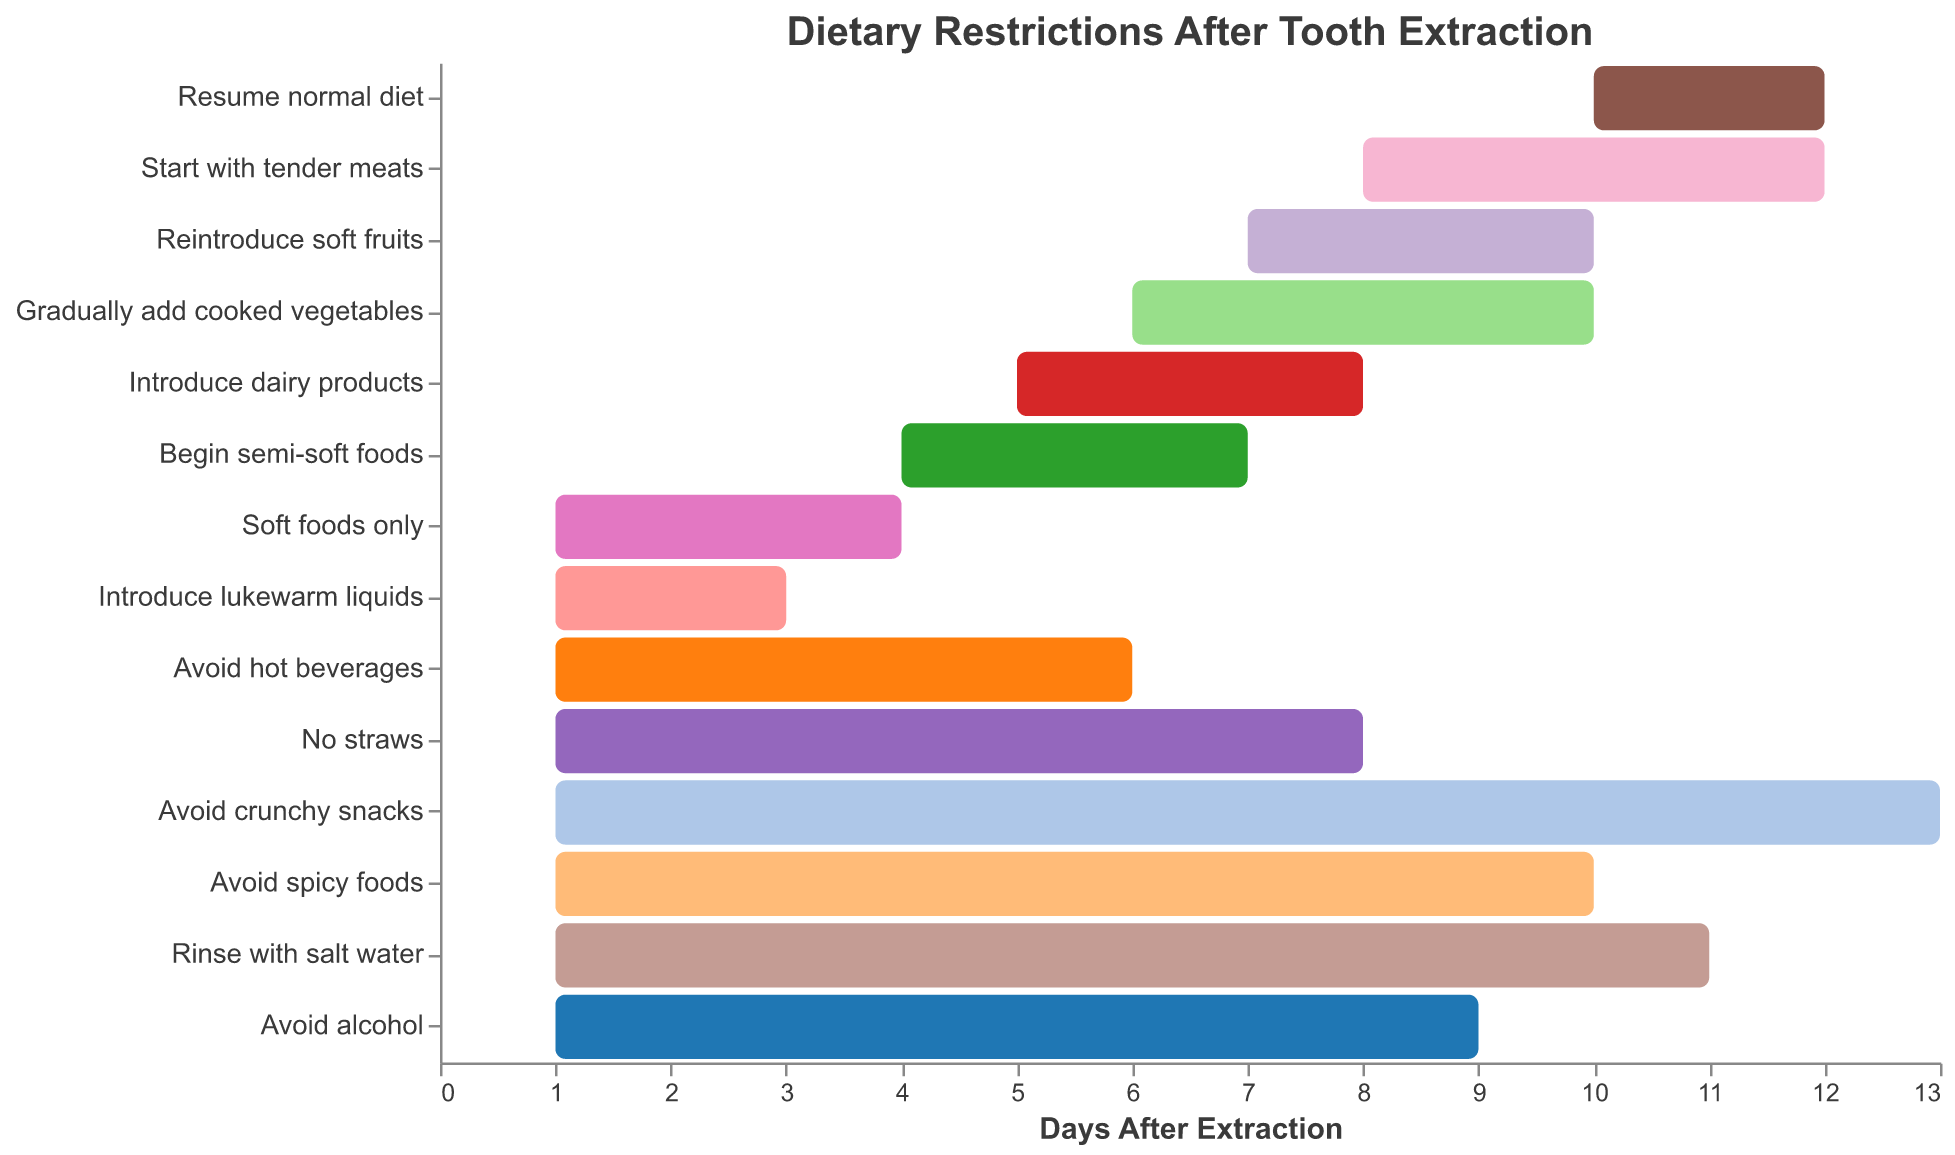What is the duration of the task "Soft foods only"? Locate the "Soft foods only" task in the figure and read its duration value.
Answer: 3 days When can I start eating tender meats after my tooth extraction? Find the task "Start with tender meats" in the figure and look for its start day.
Answer: Day 8 Which task has the longest duration? Observe all task durations and identify the one with the greatest length.
Answer: Avoid crunchy snacks What is the total duration for the task "Avoid alcohol"? Locate the "Avoid alcohol" task in the figure and read its duration value.
Answer: 8 days How many tasks start from day 1? Count all the tasks that begin on day 1.
Answer: 9 tasks Which tasks should I avoid for at least the first week? Identify tasks that either start before day 8 or end on or after day 8.
Answer: Avoid hot beverages, No straws, Avoid crunchy snacks, Avoid spicy foods, Rinse with salt water, Avoid alcohol What is the combined duration of "Avoid spicy foods" and "Rinse with salt water"? Add the durations of these two tasks together.
Answer: 19 days (9 + 10) Which food items can I start introducing on day 7? Identify tasks that start on day 7.
Answer: Reintroduce soft fruits When can I resume a normal diet? Find the task "Resume normal diet" in the figure and look for its start day.
Answer: Day 10 